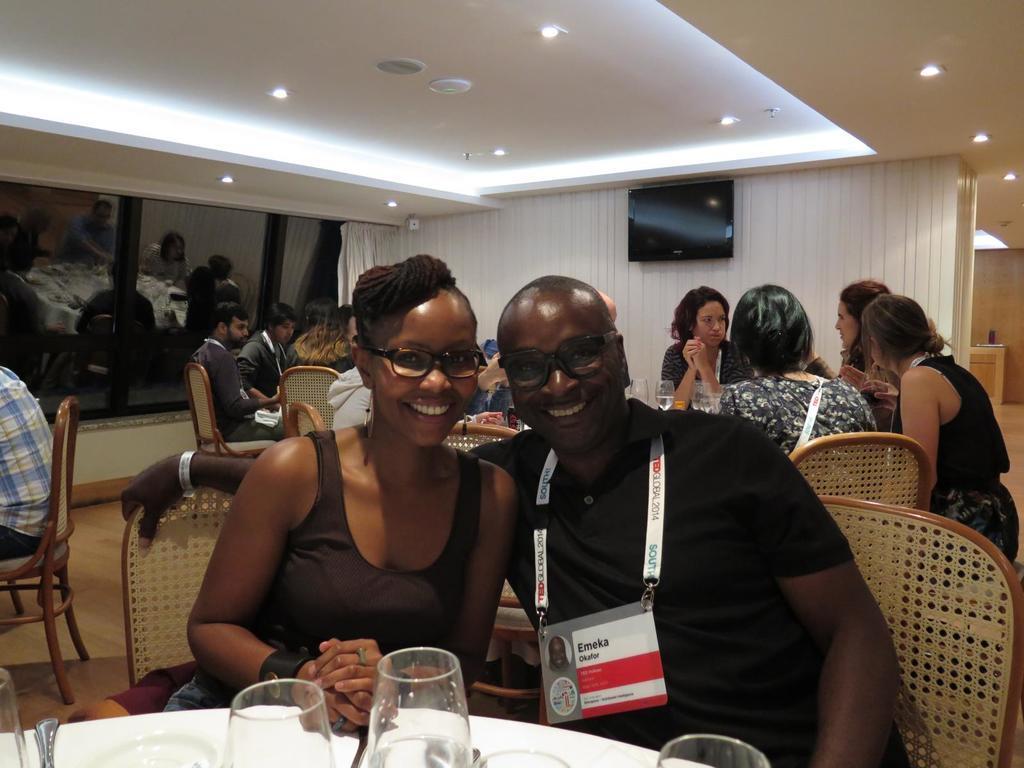In one or two sentences, can you explain what this image depicts? In this image there are two persons sitting at bottom of this image the right side person is wearing black color dress and the left one is a women and there is a table at the bottom of this image and there are some glasses kept on it and there is one person at left side of this image is sitting on the chair and there are some mirrors at left side of this image and and there is a wall in the background at right side of this image and there is a television at top of this image and there are some persons sitting at right side of this image and there are some lights arranged at top of this image. 